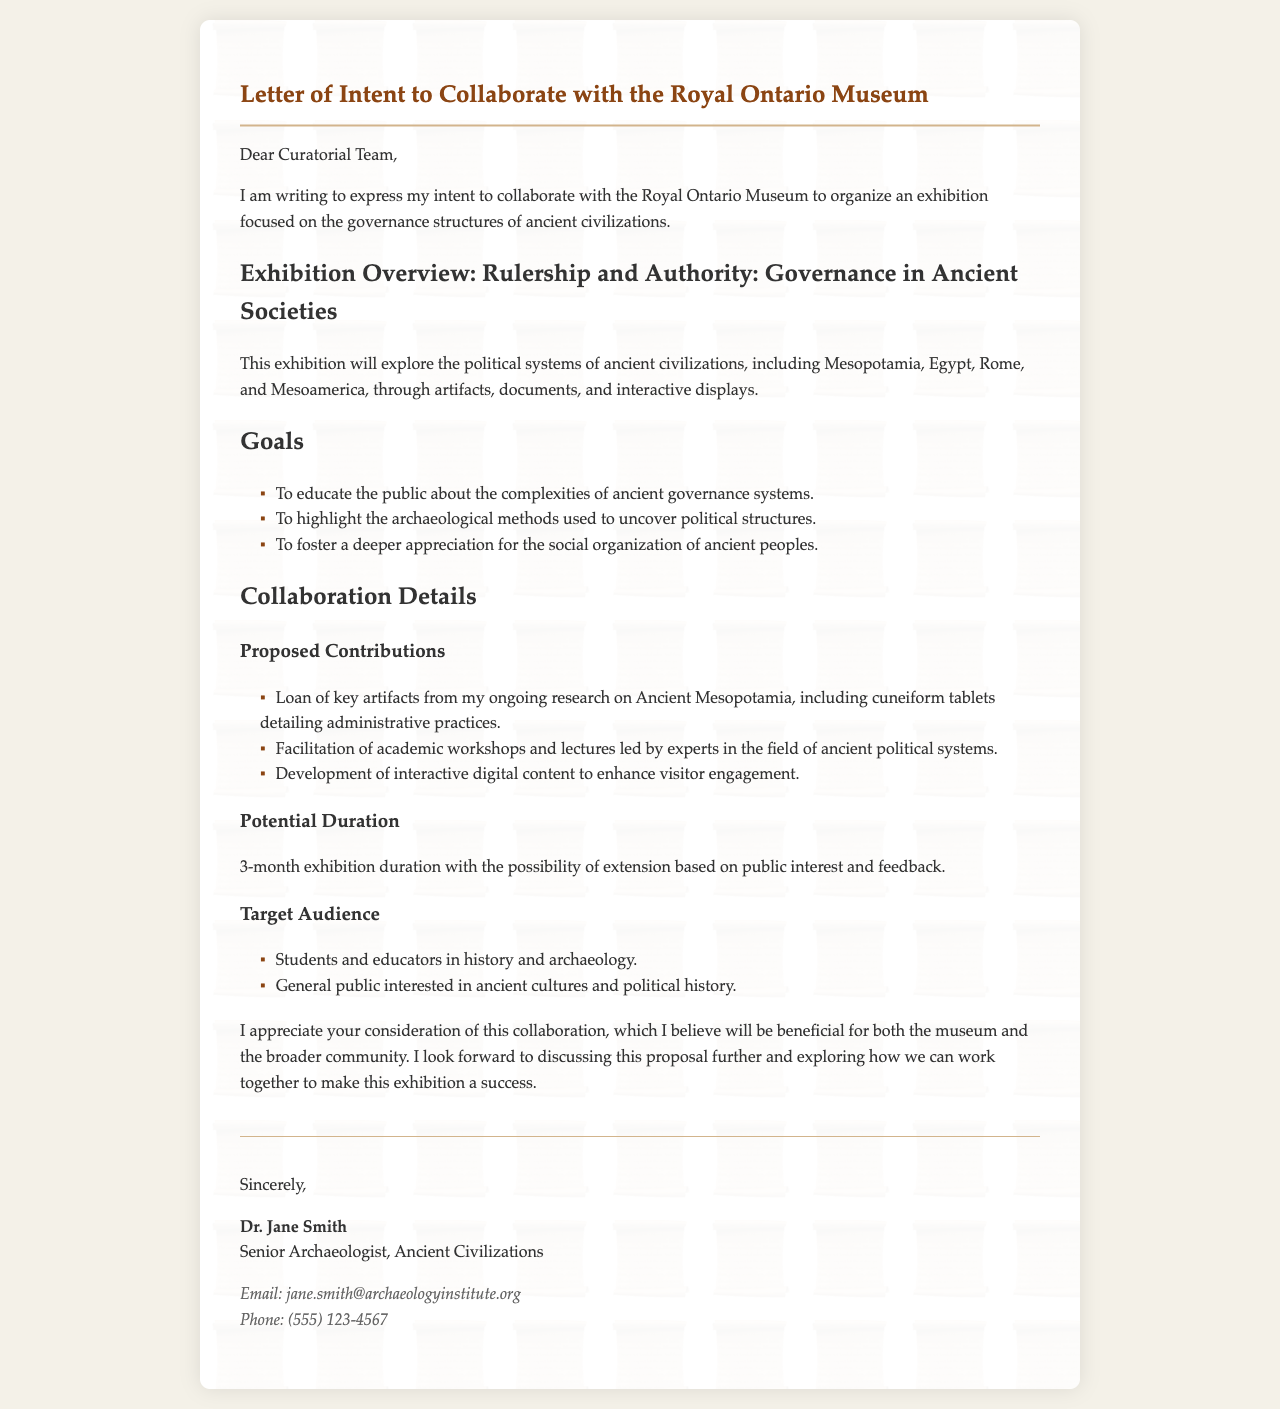What is the title of the exhibition? The title of the exhibition, as stated in the document, is explicitly mentioned under the "Exhibition Overview" section.
Answer: Rulership and Authority: Governance in Ancient Societies Who is the author of the letter? The author's name is presented in the signature section at the end of the document.
Answer: Dr. Jane Smith What is the proposed duration of the exhibition? The proposed duration is mentioned in the "Collaboration Details" section as the timeframe for the exhibition.
Answer: 3-month exhibition duration Which ancient civilizations are mentioned in the exhibition overview? The civilizational areas are listed in the "Exhibition Overview" section, demonstrating the scope of the exhibition.
Answer: Mesopotamia, Egypt, Rome, and Mesoamerica What are the proposed contributions from the author? The document lists specific contributions in the "Collaboration Details" section, providing insight into the collaboration's nature.
Answer: Loan of key artifacts, facilitation of academic workshops, development of interactive digital content Who is the target audience of the exhibition? The document outlines the intended audience in the "Collaboration Details" section to clarify the focus of the exhibition.
Answer: Students, educators, general public What is the primary goal of the exhibition? The goals are explicitly outlined in the "Goals" section, summarizing the purpose of the exhibition.
Answer: To educate the public about the complexities of ancient governance systems What is the email address of the author? The author's contact information is presented in the signature section, providing a means to reach them.
Answer: jane.smith@archaeologyinstitute.org 